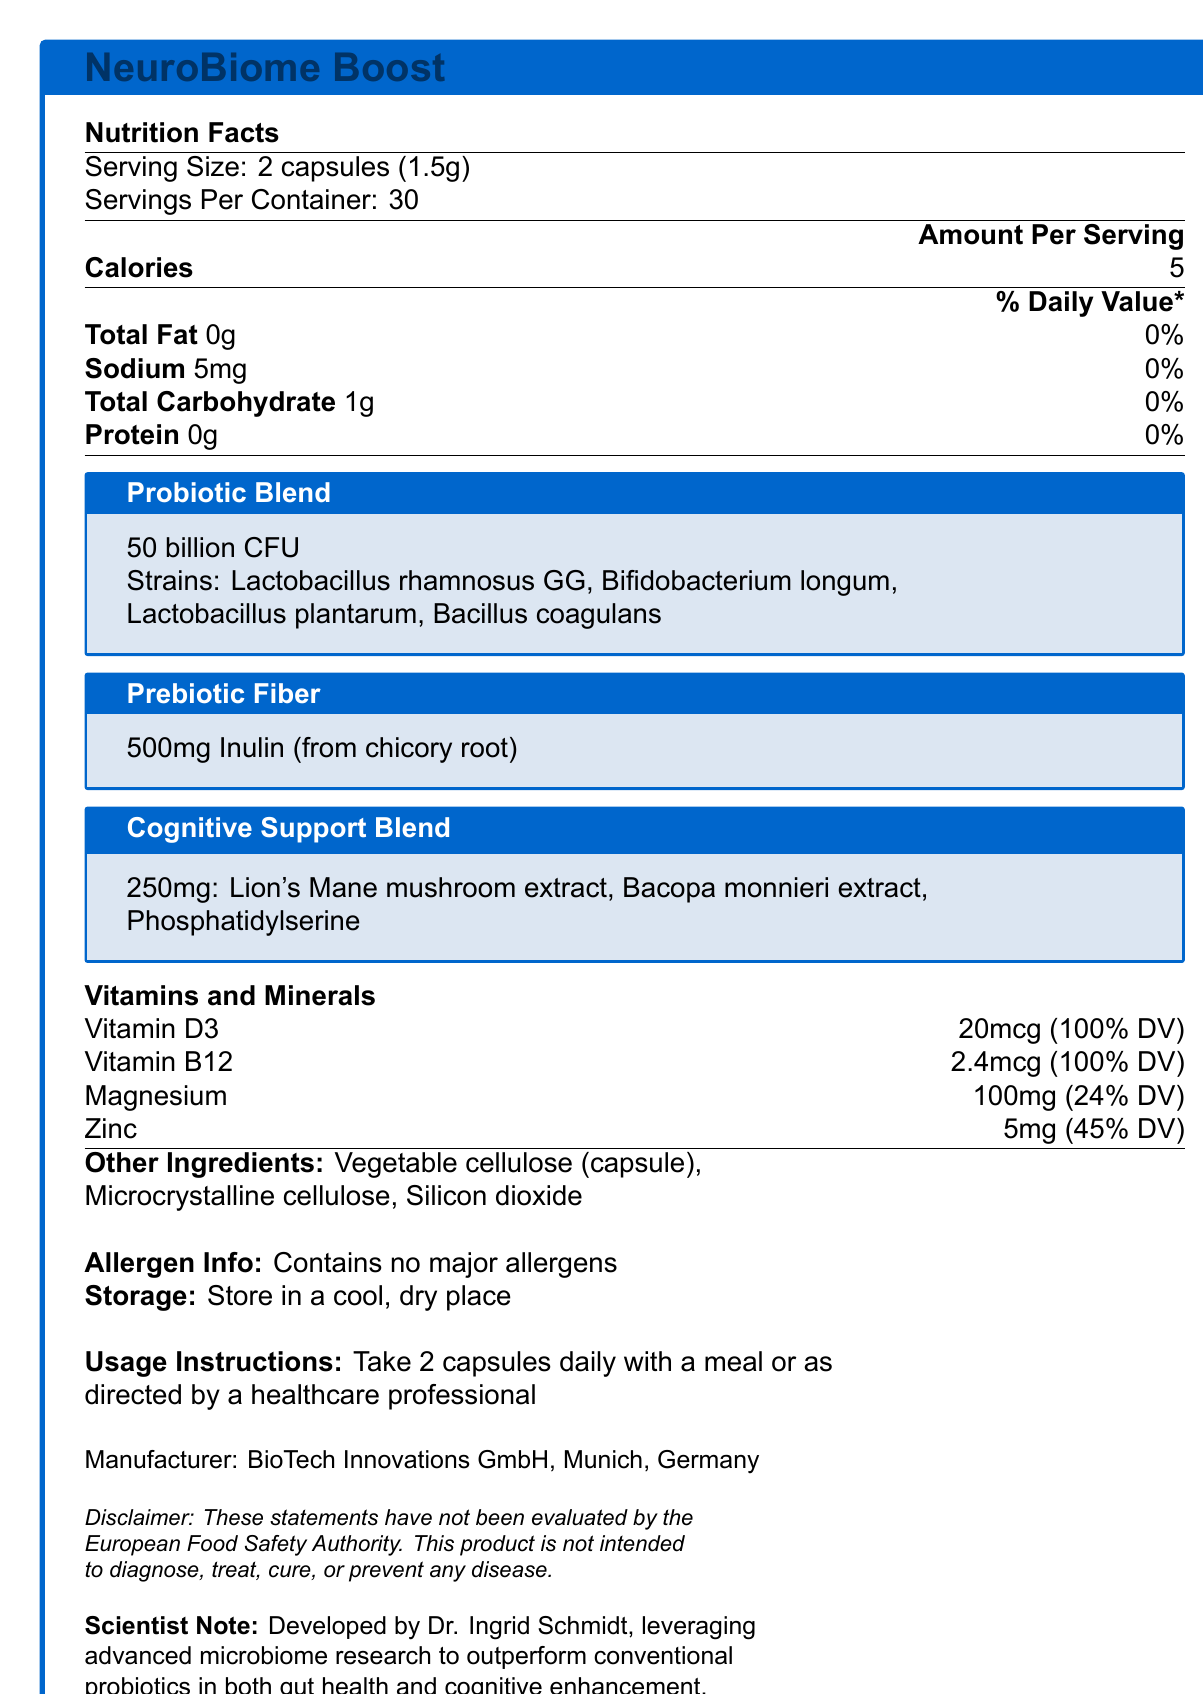what is the serving size of NeuroBiome Boost? The serving size is clearly listed at the top of the Nutrition Facts as "2 capsules (1.5g)".
Answer: 2 capsules (1.5g) how many calories does each serving of NeuroBiome Boost contain? The amount of calories per serving is provided in the Nutrition Facts section as 5.
Answer: 5 which probiotic strains are included in the probiotic blend? The probiotic blend section lists all the contained strains.
Answer: Lactobacillus rhamnosus GG, Bifidobacterium longum, Lactobacillus plantarum, Bacillus coagulans what is the main source of the prebiotic fiber in NeuroBiome Boost? The prebiotic fiber section states the source as "Inulin (from chicory root)".
Answer: Inulin (from chicory root) how much Vitamin D3 does each serving provide, and what percentage of the daily value (DV) does this represent? The "Vitamins and Minerals" section includes Vitamin D3 with an amount of 20mcg, representing 100% DV.
Answer: 20mcg (100% DV) where should NeuroBiome Boost be stored? The "Storage" section advises storing the product in a cool, dry place.
Answer: In a cool, dry place which of the following ingredients is NOT part of the Cognitive Support Blend? A. Lion's Mane mushroom extract B. Bacopa monnieri extract C. Probiotics D. Phosphatidylserine The ingredients of the Cognitive Support Blend listed are Lion's Mane mushroom extract, Bacopa monnieri extract, and Phosphatidylserine, but probiotics are not included in this blend.
Answer: C how should NeuroBiome Boost be consumed? A. With a meal B. On an empty stomach C. Twice daily without food D. Mixed with water The usage instructions specify to take 2 capsules daily with a meal, hence the correct option is A.
Answer: A does NeuroBiome Boost contain any major allergens? According to the allergen information section, the product contains no major allergens.
Answer: No who is the developer of NeuroBiome Boost? The scientist note specifies that Dr. Ingrid Schmidt developed the product.
Answer: Dr. Ingrid Schmidt what is the primary intention of NeuroBiome Boost, according to the document? The note from the scientist and the composition of the product indicate that it is aimed at optimizing gut health and cognitive function.
Answer: To optimize gut health and cognitive function how many servings are contained in one package of NeuroBiome Boost? The servings per container listed in the Nutrition Facts is 30.
Answer: 30 is Silicon dioxide one of the other ingredients in NeuroBiome Boost? The other ingredients section lists Silicon dioxide among the components.
Answer: Yes what is the serving amount of prebiotic fiber in NeuroBiome Boost? According to the Prebiotic Fiber section, the amount is 500mg.
Answer: 500mg is the amount of Magnesium in NeuroBiome Boost 33% of the daily value? The amount of Magnesium listed is 100mg, which is 24% of the daily value.
Answer: No summarize the main idea and important details of the NeuroBiome Boost Nutrition Facts Label This summary encapsulates the main features and components of the NeuroBiome Boost to provide a comprehensive understanding of the product.
Answer: NeuroBiome Boost is a probiotic-rich food supplement aimed at optimizing gut health and cognitive function. Each serving of two capsules provides 5 calories and essential nutrients like Vitamin D3 and Vitamin B12. Key components include a 50 billion CFU probiotic blend, 500mg of prebiotic fiber from inulin, and a 250mg cognitive support blend with extracts such as Lion's Mane mushroom and Bacopa monnieri. The product contains no major allergens and should be stored in a cool, dry place. It is manufactured by BioTech Innovations GmbH and developed by Dr. Ingrid Schmidt. what are the clinical study results for NeuroBiome Boost? The document does not provide any details about clinical study results for NeuroBiome Boost.
Answer: Not enough information 